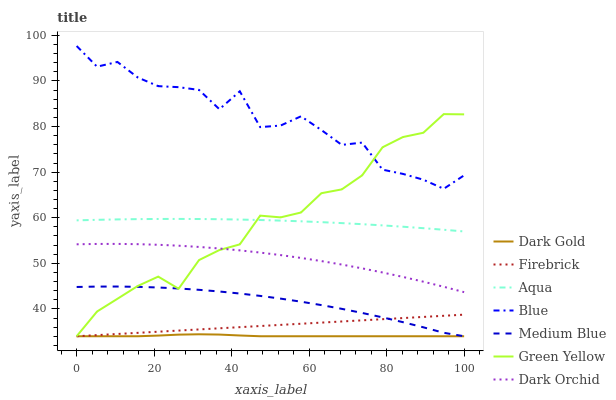Does Dark Gold have the minimum area under the curve?
Answer yes or no. Yes. Does Blue have the maximum area under the curve?
Answer yes or no. Yes. Does Aqua have the minimum area under the curve?
Answer yes or no. No. Does Aqua have the maximum area under the curve?
Answer yes or no. No. Is Firebrick the smoothest?
Answer yes or no. Yes. Is Blue the roughest?
Answer yes or no. Yes. Is Dark Gold the smoothest?
Answer yes or no. No. Is Dark Gold the roughest?
Answer yes or no. No. Does Aqua have the lowest value?
Answer yes or no. No. Does Blue have the highest value?
Answer yes or no. Yes. Does Aqua have the highest value?
Answer yes or no. No. Is Medium Blue less than Dark Orchid?
Answer yes or no. Yes. Is Aqua greater than Dark Gold?
Answer yes or no. Yes. Does Firebrick intersect Green Yellow?
Answer yes or no. Yes. Is Firebrick less than Green Yellow?
Answer yes or no. No. Is Firebrick greater than Green Yellow?
Answer yes or no. No. Does Medium Blue intersect Dark Orchid?
Answer yes or no. No. 